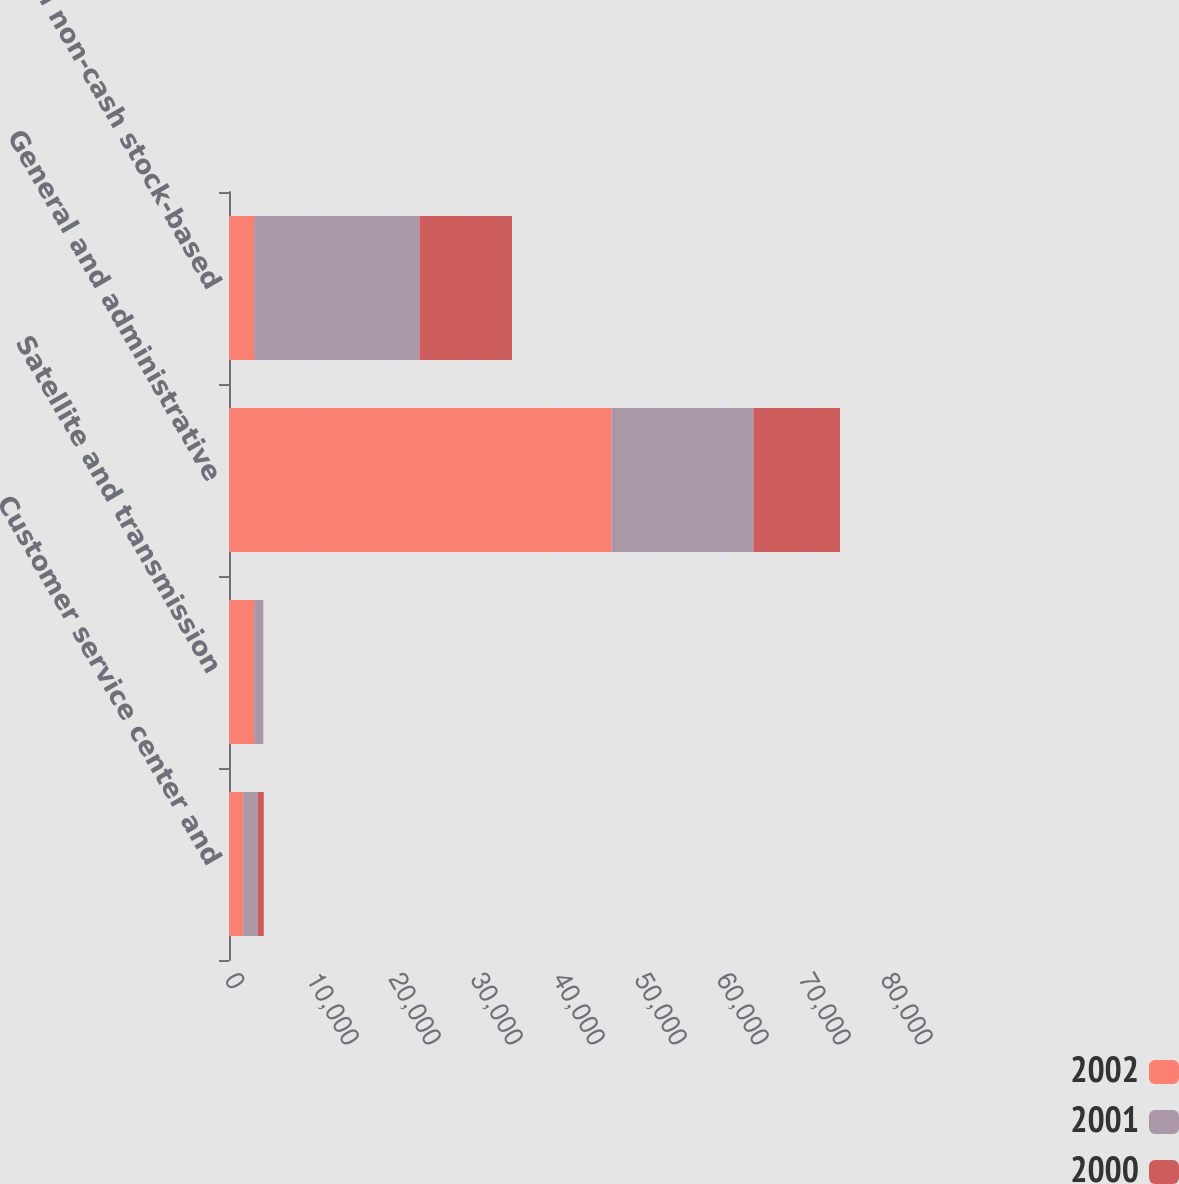<chart> <loc_0><loc_0><loc_500><loc_500><stacked_bar_chart><ecel><fcel>Customer service center and<fcel>Satellite and transmission<fcel>General and administrative<fcel>Total non-cash stock-based<nl><fcel>2002<fcel>1744<fcel>3061<fcel>46660<fcel>3061<nl><fcel>2001<fcel>1767<fcel>1115<fcel>17291<fcel>20173<nl><fcel>2000<fcel>729<fcel>7<fcel>10557<fcel>11279<nl></chart> 